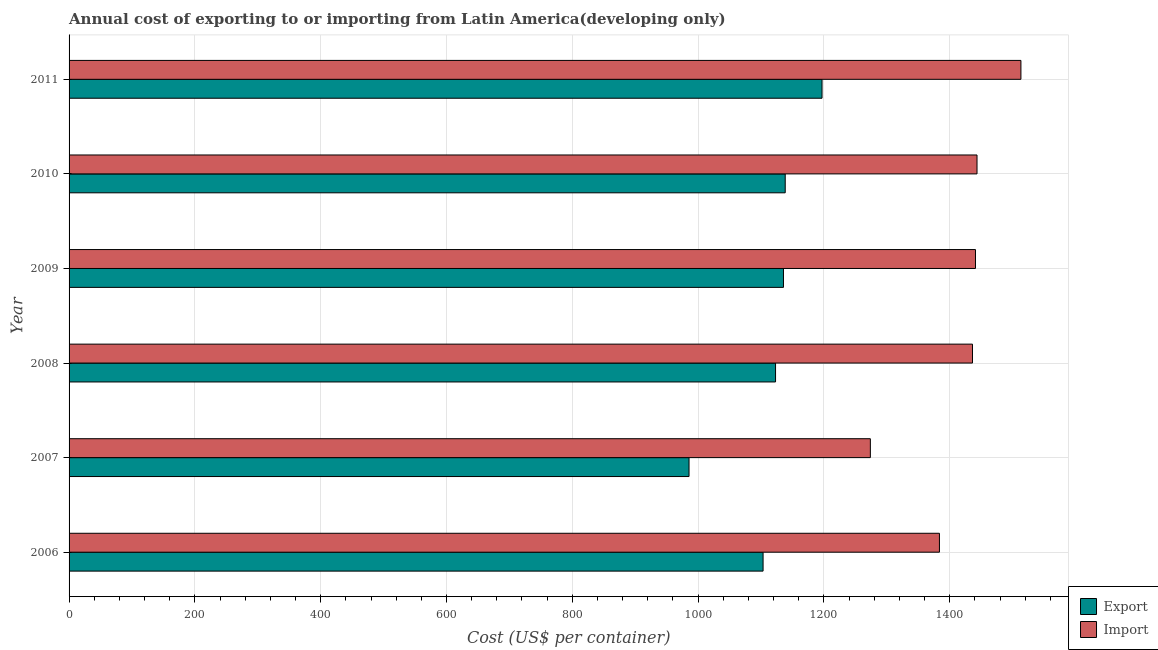How many different coloured bars are there?
Your answer should be very brief. 2. Are the number of bars on each tick of the Y-axis equal?
Your answer should be very brief. Yes. How many bars are there on the 3rd tick from the top?
Provide a short and direct response. 2. What is the label of the 5th group of bars from the top?
Keep it short and to the point. 2007. What is the import cost in 2011?
Make the answer very short. 1513.22. Across all years, what is the maximum export cost?
Offer a terse response. 1197.04. Across all years, what is the minimum export cost?
Offer a very short reply. 985.61. What is the total export cost in the graph?
Keep it short and to the point. 6683.35. What is the difference between the import cost in 2006 and that in 2010?
Ensure brevity in your answer.  -59.74. What is the difference between the import cost in 2011 and the export cost in 2007?
Provide a succinct answer. 527.61. What is the average import cost per year?
Offer a very short reply. 1415.24. In the year 2008, what is the difference between the import cost and export cost?
Your answer should be compact. 313.09. In how many years, is the import cost greater than 1160 US$?
Offer a very short reply. 6. What is the ratio of the export cost in 2006 to that in 2011?
Offer a very short reply. 0.92. What is the difference between the highest and the second highest import cost?
Your response must be concise. 69.78. What is the difference between the highest and the lowest import cost?
Give a very brief answer. 239.35. In how many years, is the export cost greater than the average export cost taken over all years?
Your answer should be compact. 4. What does the 2nd bar from the top in 2010 represents?
Offer a terse response. Export. What does the 2nd bar from the bottom in 2006 represents?
Your answer should be compact. Import. How many bars are there?
Provide a succinct answer. 12. Are all the bars in the graph horizontal?
Offer a very short reply. Yes. Are the values on the major ticks of X-axis written in scientific E-notation?
Your answer should be compact. No. Where does the legend appear in the graph?
Keep it short and to the point. Bottom right. How many legend labels are there?
Give a very brief answer. 2. How are the legend labels stacked?
Ensure brevity in your answer.  Vertical. What is the title of the graph?
Offer a very short reply. Annual cost of exporting to or importing from Latin America(developing only). Does "Domestic liabilities" appear as one of the legend labels in the graph?
Your answer should be very brief. No. What is the label or title of the X-axis?
Give a very brief answer. Cost (US$ per container). What is the label or title of the Y-axis?
Your response must be concise. Year. What is the Cost (US$ per container) in Export in 2006?
Your answer should be compact. 1103.3. What is the Cost (US$ per container) in Import in 2006?
Your answer should be very brief. 1383.7. What is the Cost (US$ per container) of Export in 2007?
Ensure brevity in your answer.  985.61. What is the Cost (US$ per container) in Import in 2007?
Your response must be concise. 1273.87. What is the Cost (US$ per container) in Export in 2008?
Ensure brevity in your answer.  1123.13. What is the Cost (US$ per container) of Import in 2008?
Provide a succinct answer. 1436.22. What is the Cost (US$ per container) in Export in 2009?
Your answer should be very brief. 1135.74. What is the Cost (US$ per container) in Import in 2009?
Give a very brief answer. 1441. What is the Cost (US$ per container) of Export in 2010?
Give a very brief answer. 1138.52. What is the Cost (US$ per container) in Import in 2010?
Provide a succinct answer. 1443.43. What is the Cost (US$ per container) in Export in 2011?
Your answer should be compact. 1197.04. What is the Cost (US$ per container) of Import in 2011?
Offer a very short reply. 1513.22. Across all years, what is the maximum Cost (US$ per container) in Export?
Your answer should be very brief. 1197.04. Across all years, what is the maximum Cost (US$ per container) of Import?
Provide a succinct answer. 1513.22. Across all years, what is the minimum Cost (US$ per container) of Export?
Provide a short and direct response. 985.61. Across all years, what is the minimum Cost (US$ per container) of Import?
Provide a succinct answer. 1273.87. What is the total Cost (US$ per container) in Export in the graph?
Provide a succinct answer. 6683.35. What is the total Cost (US$ per container) of Import in the graph?
Your response must be concise. 8491.43. What is the difference between the Cost (US$ per container) in Export in 2006 and that in 2007?
Your answer should be very brief. 117.7. What is the difference between the Cost (US$ per container) in Import in 2006 and that in 2007?
Ensure brevity in your answer.  109.83. What is the difference between the Cost (US$ per container) of Export in 2006 and that in 2008?
Give a very brief answer. -19.83. What is the difference between the Cost (US$ per container) in Import in 2006 and that in 2008?
Provide a succinct answer. -52.52. What is the difference between the Cost (US$ per container) in Export in 2006 and that in 2009?
Provide a short and direct response. -32.43. What is the difference between the Cost (US$ per container) in Import in 2006 and that in 2009?
Make the answer very short. -57.3. What is the difference between the Cost (US$ per container) of Export in 2006 and that in 2010?
Provide a short and direct response. -35.22. What is the difference between the Cost (US$ per container) of Import in 2006 and that in 2010?
Your response must be concise. -59.74. What is the difference between the Cost (US$ per container) of Export in 2006 and that in 2011?
Offer a terse response. -93.74. What is the difference between the Cost (US$ per container) in Import in 2006 and that in 2011?
Offer a very short reply. -129.52. What is the difference between the Cost (US$ per container) of Export in 2007 and that in 2008?
Make the answer very short. -137.52. What is the difference between the Cost (US$ per container) of Import in 2007 and that in 2008?
Provide a short and direct response. -162.35. What is the difference between the Cost (US$ per container) of Export in 2007 and that in 2009?
Offer a very short reply. -150.13. What is the difference between the Cost (US$ per container) in Import in 2007 and that in 2009?
Offer a terse response. -167.13. What is the difference between the Cost (US$ per container) in Export in 2007 and that in 2010?
Offer a very short reply. -152.91. What is the difference between the Cost (US$ per container) in Import in 2007 and that in 2010?
Provide a short and direct response. -169.57. What is the difference between the Cost (US$ per container) in Export in 2007 and that in 2011?
Your answer should be compact. -211.43. What is the difference between the Cost (US$ per container) in Import in 2007 and that in 2011?
Your answer should be compact. -239.35. What is the difference between the Cost (US$ per container) in Export in 2008 and that in 2009?
Your response must be concise. -12.61. What is the difference between the Cost (US$ per container) in Import in 2008 and that in 2009?
Your answer should be very brief. -4.78. What is the difference between the Cost (US$ per container) in Export in 2008 and that in 2010?
Give a very brief answer. -15.39. What is the difference between the Cost (US$ per container) of Import in 2008 and that in 2010?
Your response must be concise. -7.22. What is the difference between the Cost (US$ per container) of Export in 2008 and that in 2011?
Make the answer very short. -73.91. What is the difference between the Cost (US$ per container) in Import in 2008 and that in 2011?
Your response must be concise. -77. What is the difference between the Cost (US$ per container) of Export in 2009 and that in 2010?
Your response must be concise. -2.78. What is the difference between the Cost (US$ per container) of Import in 2009 and that in 2010?
Provide a short and direct response. -2.43. What is the difference between the Cost (US$ per container) of Export in 2009 and that in 2011?
Give a very brief answer. -61.3. What is the difference between the Cost (US$ per container) of Import in 2009 and that in 2011?
Provide a short and direct response. -72.22. What is the difference between the Cost (US$ per container) of Export in 2010 and that in 2011?
Provide a succinct answer. -58.52. What is the difference between the Cost (US$ per container) in Import in 2010 and that in 2011?
Keep it short and to the point. -69.78. What is the difference between the Cost (US$ per container) in Export in 2006 and the Cost (US$ per container) in Import in 2007?
Your answer should be compact. -170.57. What is the difference between the Cost (US$ per container) of Export in 2006 and the Cost (US$ per container) of Import in 2008?
Your answer should be very brief. -332.91. What is the difference between the Cost (US$ per container) of Export in 2006 and the Cost (US$ per container) of Import in 2009?
Offer a very short reply. -337.7. What is the difference between the Cost (US$ per container) in Export in 2006 and the Cost (US$ per container) in Import in 2010?
Ensure brevity in your answer.  -340.13. What is the difference between the Cost (US$ per container) of Export in 2006 and the Cost (US$ per container) of Import in 2011?
Make the answer very short. -409.91. What is the difference between the Cost (US$ per container) of Export in 2007 and the Cost (US$ per container) of Import in 2008?
Offer a terse response. -450.61. What is the difference between the Cost (US$ per container) in Export in 2007 and the Cost (US$ per container) in Import in 2009?
Give a very brief answer. -455.39. What is the difference between the Cost (US$ per container) of Export in 2007 and the Cost (US$ per container) of Import in 2010?
Offer a very short reply. -457.83. What is the difference between the Cost (US$ per container) in Export in 2007 and the Cost (US$ per container) in Import in 2011?
Your response must be concise. -527.61. What is the difference between the Cost (US$ per container) in Export in 2008 and the Cost (US$ per container) in Import in 2009?
Your answer should be compact. -317.87. What is the difference between the Cost (US$ per container) in Export in 2008 and the Cost (US$ per container) in Import in 2010?
Make the answer very short. -320.3. What is the difference between the Cost (US$ per container) of Export in 2008 and the Cost (US$ per container) of Import in 2011?
Offer a terse response. -390.09. What is the difference between the Cost (US$ per container) of Export in 2009 and the Cost (US$ per container) of Import in 2010?
Offer a very short reply. -307.7. What is the difference between the Cost (US$ per container) of Export in 2009 and the Cost (US$ per container) of Import in 2011?
Ensure brevity in your answer.  -377.48. What is the difference between the Cost (US$ per container) in Export in 2010 and the Cost (US$ per container) in Import in 2011?
Make the answer very short. -374.7. What is the average Cost (US$ per container) of Export per year?
Keep it short and to the point. 1113.89. What is the average Cost (US$ per container) of Import per year?
Provide a succinct answer. 1415.24. In the year 2006, what is the difference between the Cost (US$ per container) of Export and Cost (US$ per container) of Import?
Your answer should be compact. -280.39. In the year 2007, what is the difference between the Cost (US$ per container) of Export and Cost (US$ per container) of Import?
Give a very brief answer. -288.26. In the year 2008, what is the difference between the Cost (US$ per container) in Export and Cost (US$ per container) in Import?
Your response must be concise. -313.09. In the year 2009, what is the difference between the Cost (US$ per container) of Export and Cost (US$ per container) of Import?
Give a very brief answer. -305.26. In the year 2010, what is the difference between the Cost (US$ per container) of Export and Cost (US$ per container) of Import?
Your response must be concise. -304.91. In the year 2011, what is the difference between the Cost (US$ per container) of Export and Cost (US$ per container) of Import?
Your response must be concise. -316.17. What is the ratio of the Cost (US$ per container) of Export in 2006 to that in 2007?
Offer a very short reply. 1.12. What is the ratio of the Cost (US$ per container) of Import in 2006 to that in 2007?
Provide a succinct answer. 1.09. What is the ratio of the Cost (US$ per container) in Export in 2006 to that in 2008?
Keep it short and to the point. 0.98. What is the ratio of the Cost (US$ per container) of Import in 2006 to that in 2008?
Your answer should be very brief. 0.96. What is the ratio of the Cost (US$ per container) in Export in 2006 to that in 2009?
Your answer should be very brief. 0.97. What is the ratio of the Cost (US$ per container) of Import in 2006 to that in 2009?
Offer a terse response. 0.96. What is the ratio of the Cost (US$ per container) in Export in 2006 to that in 2010?
Give a very brief answer. 0.97. What is the ratio of the Cost (US$ per container) in Import in 2006 to that in 2010?
Your response must be concise. 0.96. What is the ratio of the Cost (US$ per container) in Export in 2006 to that in 2011?
Keep it short and to the point. 0.92. What is the ratio of the Cost (US$ per container) of Import in 2006 to that in 2011?
Provide a short and direct response. 0.91. What is the ratio of the Cost (US$ per container) of Export in 2007 to that in 2008?
Offer a very short reply. 0.88. What is the ratio of the Cost (US$ per container) in Import in 2007 to that in 2008?
Your answer should be very brief. 0.89. What is the ratio of the Cost (US$ per container) of Export in 2007 to that in 2009?
Make the answer very short. 0.87. What is the ratio of the Cost (US$ per container) in Import in 2007 to that in 2009?
Keep it short and to the point. 0.88. What is the ratio of the Cost (US$ per container) in Export in 2007 to that in 2010?
Your answer should be very brief. 0.87. What is the ratio of the Cost (US$ per container) of Import in 2007 to that in 2010?
Provide a succinct answer. 0.88. What is the ratio of the Cost (US$ per container) in Export in 2007 to that in 2011?
Offer a terse response. 0.82. What is the ratio of the Cost (US$ per container) of Import in 2007 to that in 2011?
Offer a very short reply. 0.84. What is the ratio of the Cost (US$ per container) of Export in 2008 to that in 2009?
Provide a short and direct response. 0.99. What is the ratio of the Cost (US$ per container) in Export in 2008 to that in 2010?
Keep it short and to the point. 0.99. What is the ratio of the Cost (US$ per container) of Export in 2008 to that in 2011?
Your response must be concise. 0.94. What is the ratio of the Cost (US$ per container) in Import in 2008 to that in 2011?
Provide a short and direct response. 0.95. What is the ratio of the Cost (US$ per container) in Export in 2009 to that in 2010?
Keep it short and to the point. 1. What is the ratio of the Cost (US$ per container) of Import in 2009 to that in 2010?
Your answer should be compact. 1. What is the ratio of the Cost (US$ per container) of Export in 2009 to that in 2011?
Provide a succinct answer. 0.95. What is the ratio of the Cost (US$ per container) in Import in 2009 to that in 2011?
Keep it short and to the point. 0.95. What is the ratio of the Cost (US$ per container) in Export in 2010 to that in 2011?
Give a very brief answer. 0.95. What is the ratio of the Cost (US$ per container) in Import in 2010 to that in 2011?
Make the answer very short. 0.95. What is the difference between the highest and the second highest Cost (US$ per container) of Export?
Offer a terse response. 58.52. What is the difference between the highest and the second highest Cost (US$ per container) of Import?
Your answer should be compact. 69.78. What is the difference between the highest and the lowest Cost (US$ per container) in Export?
Give a very brief answer. 211.43. What is the difference between the highest and the lowest Cost (US$ per container) of Import?
Your answer should be compact. 239.35. 